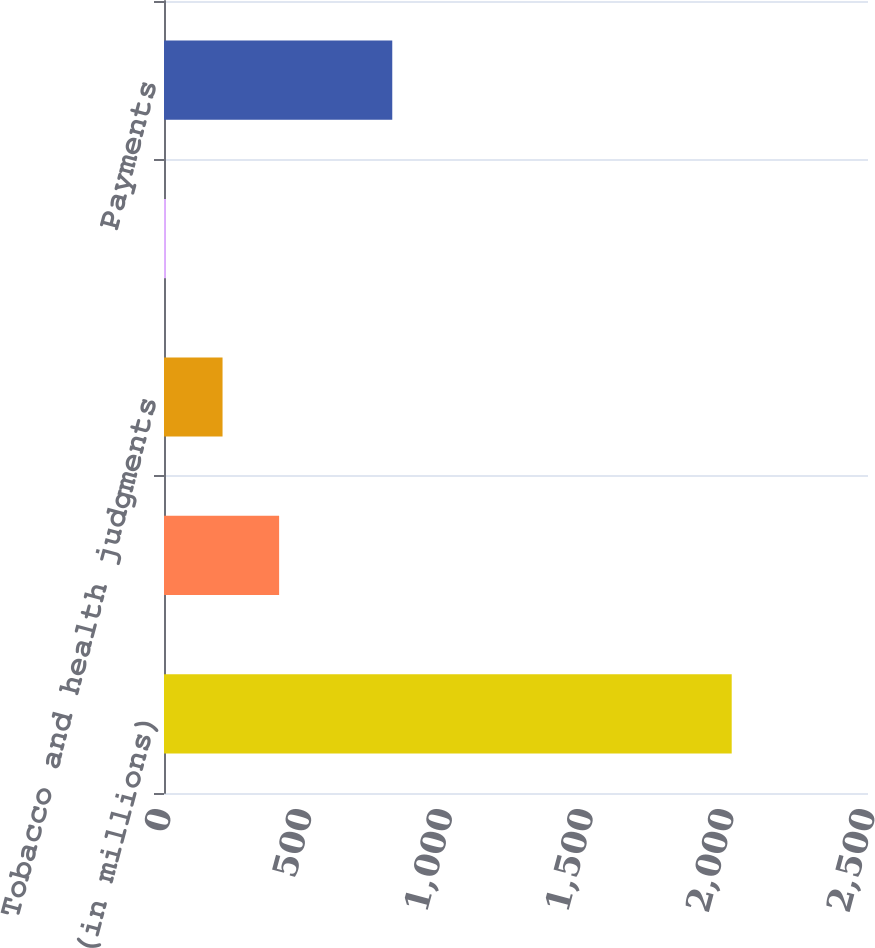<chart> <loc_0><loc_0><loc_500><loc_500><bar_chart><fcel>(in millions)<fcel>Accrued liability for tobacco<fcel>Tobacco and health judgments<fcel>Related interest costs<fcel>Payments<nl><fcel>2016<fcel>408.8<fcel>207.9<fcel>7<fcel>810.6<nl></chart> 